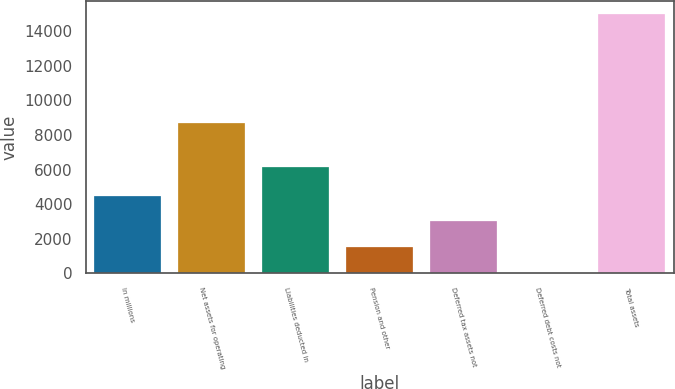Convert chart. <chart><loc_0><loc_0><loc_500><loc_500><bar_chart><fcel>In millions<fcel>Net assets for operating<fcel>Liabilities deducted in<fcel>Pension and other<fcel>Deferred tax assets not<fcel>Deferred debt costs not<fcel>Total assets<nl><fcel>4504.7<fcel>8721<fcel>6152<fcel>1502.9<fcel>3003.8<fcel>2<fcel>15011<nl></chart> 